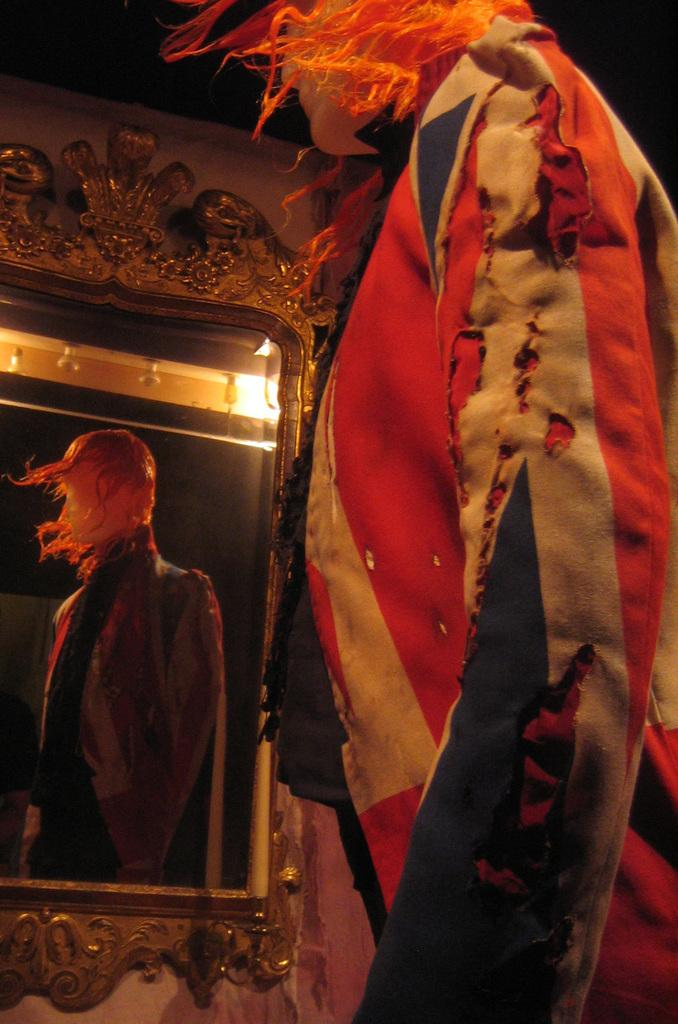What is the main subject in the foreground of the picture? There is a mannequin in the foreground of the picture. Can you describe any other objects or features in the picture? There is a mirror on the left side of the picture. What type of beef is being regretted by the mannequin in the picture? There is no beef or any indication of regret in the picture; it features a mannequin and a mirror. 